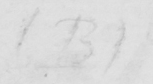Can you read and transcribe this handwriting? ( B ) 